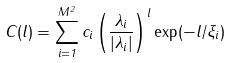Convert formula to latex. <formula><loc_0><loc_0><loc_500><loc_500>C ( l ) = \sum _ { i = 1 } ^ { M ^ { 2 } } c _ { i } \left ( \frac { \lambda _ { i } } { | \lambda _ { i } | } \right ) ^ { l } \exp ( - l / \xi _ { i } )</formula> 